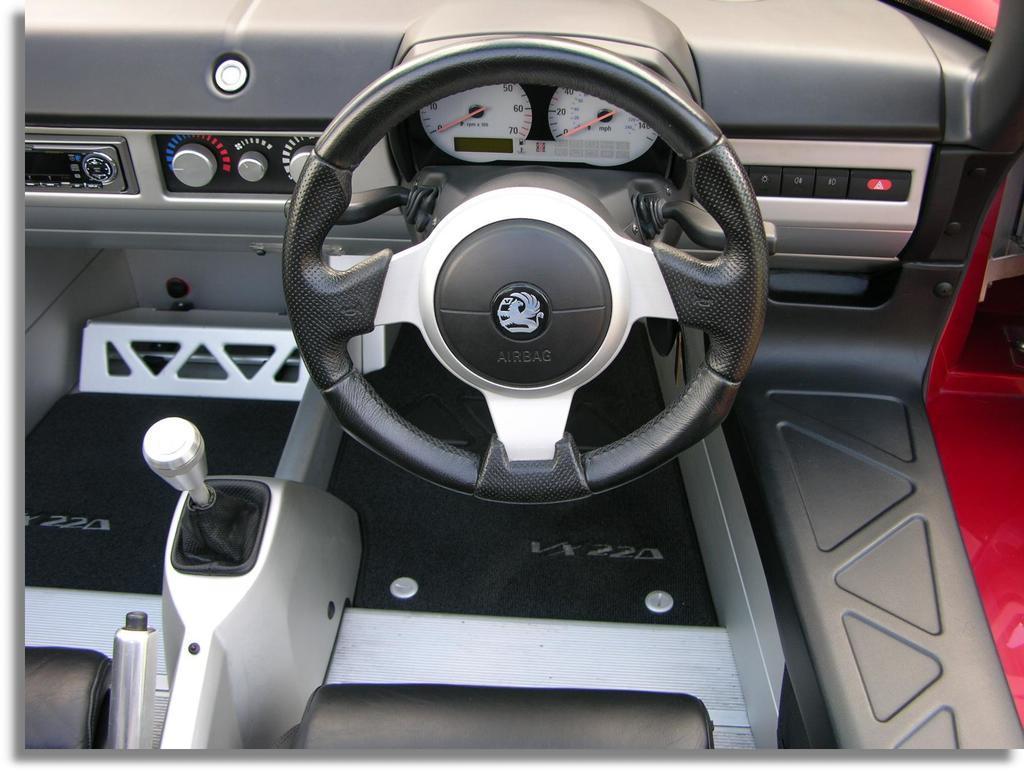Describe this image in one or two sentences. This image is inside a vehicle where we can see the steering, meter readings, gear rod and a few more things. 